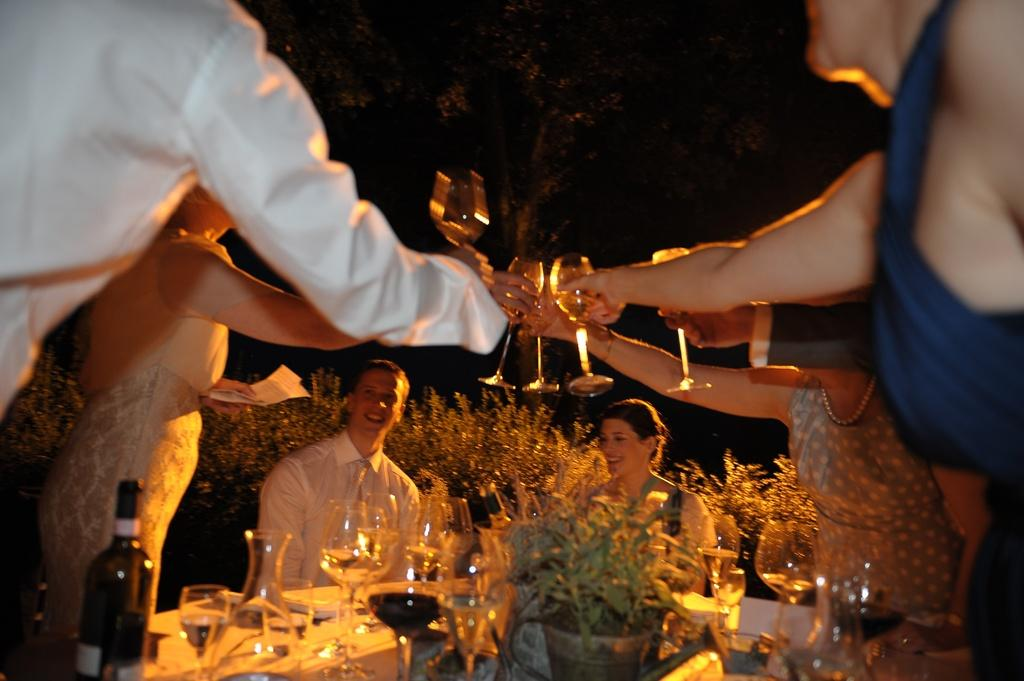What are the people in the image doing? Some people are sitting and some are standing in the image. What is on the table in the image? There are glasses and other objects on the table. What can be seen in the background of the image? There is a tree in the background of the image. What is the title of the book that the people are reading in the image? There is no book or reading activity depicted in the image. How many prison cells can be seen in the image? There are no prison cells present in the image. 